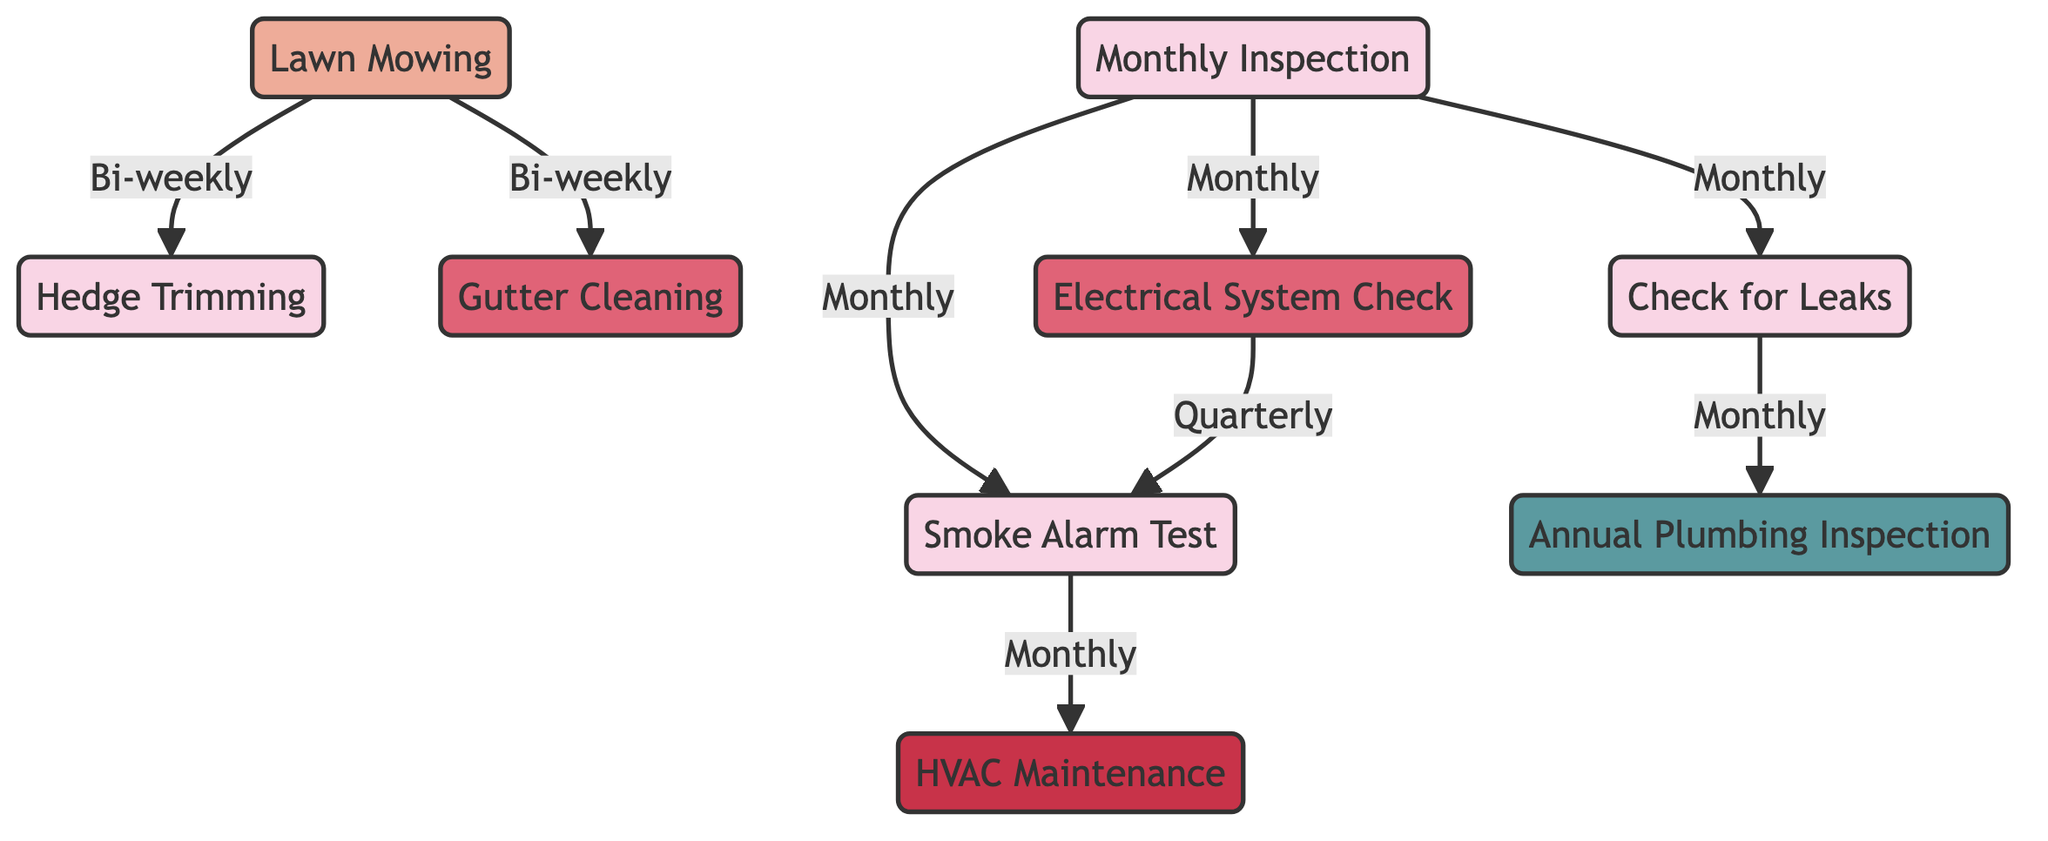What is the frequency of Lawn Mowing? The diagram indicates that Lawn Mowing is scheduled to occur Bi-weekly, as indicated by its label and the assigned color code that specifies the frequency type.
Answer: Bi-weekly How many nodes are there in the diagram? By counting the distinct tasks listed in the nodes section, we find there are nine unique tasks present in the diagram.
Answer: Nine What task depends on Monthly Inspection? In the diagram, the arrows originating from Monthly Inspection indicate that it is linked to Check for Leaks, Electrical System Check, and Smoke Alarm Test, showing these tasks rely on it being completed first.
Answer: Check for Leaks, Electrical System Check, Smoke Alarm Test What is the relationship between Smoke Alarm Test and HVAC Maintenance? The diagram shows that Smoke Alarm Test points to HVAC Maintenance, indicating that the HVAC Maintenance task is dependent on the completion of Smoke Alarm Test, which must be performed beforehand as part of the inspection.
Answer: Smoke Alarm Test → HVAC Maintenance Which task is performed annually? Referring to the frequencies listed, we see that Annual Plumbing Inspection is the only task denoted with the annual frequency, indicating it occurs one time each year.
Answer: Annual Plumbing Inspection What is the dependency chain for HVAC Maintenance? To find the dependency chain, we start with HVAC Maintenance, which depends on Smoke Alarm Test (12). Smoke Alarm Test is linked back to Monthly Inspection (1) as required prior activity. Thus, the chain of dependencies is Monthly Inspection → Smoke Alarm Test → HVAC Maintenance.
Answer: Monthly Inspection → Smoke Alarm Test → HVAC Maintenance How often is Gutter Cleaning scheduled? The diagram specifies that Gutter Cleaning’s frequency is set to Quarterly, denoted alongside the task label with its corresponding color code.
Answer: Quarterly Which tasks are performed monthly? By reviewing the frequency details associated with the tasks, we find that Monthly Inspection, Hedge Trimming, Check for Leaks, and Smoke Alarm Test are all scheduled to occur each month.
Answer: Monthly Inspection, Hedge Trimming, Check for Leaks, Smoke Alarm Test Which task has the least frequent maintenance schedule? Upon evaluating the frequency of all tasks, Annual Plumbing Inspection is noted as having the least frequent maintenance schedule, indicated as it occurs only once per year.
Answer: Annual Plumbing Inspection 